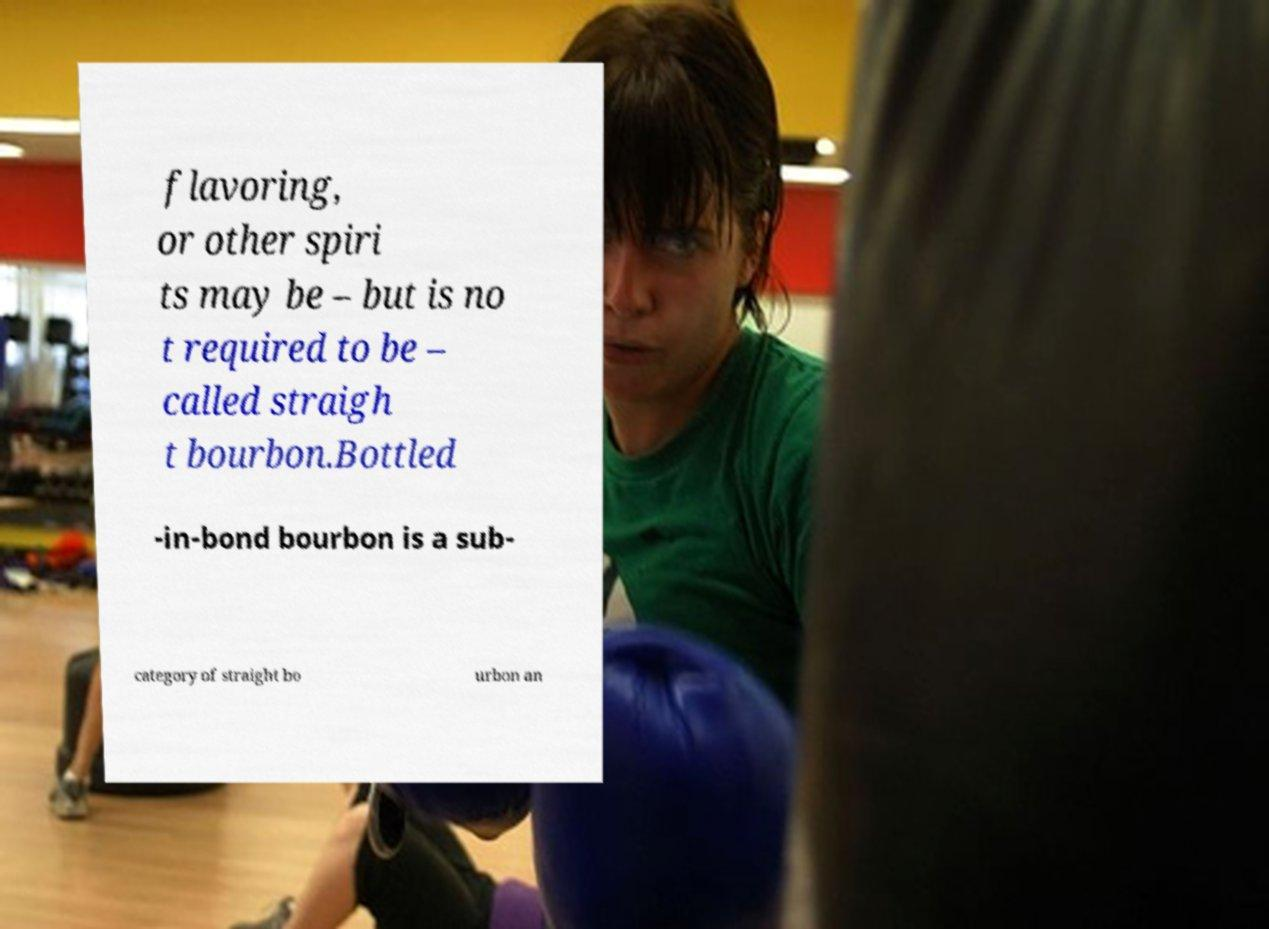Could you extract and type out the text from this image? flavoring, or other spiri ts may be – but is no t required to be – called straigh t bourbon.Bottled -in-bond bourbon is a sub- category of straight bo urbon an 